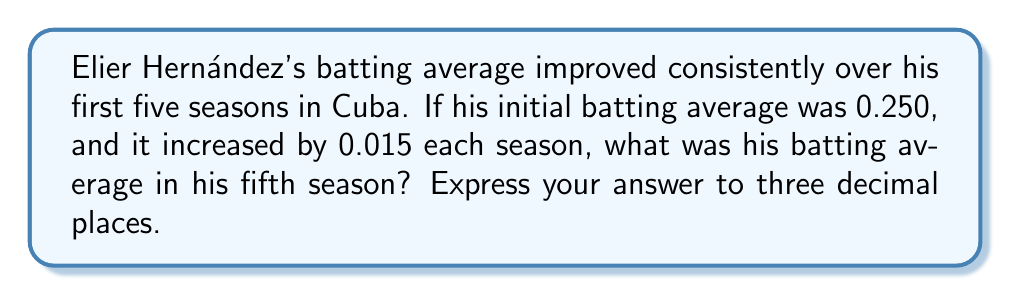Give your solution to this math problem. Let's approach this step-by-step:

1) We start with Hernández's initial batting average:
   $a_1 = 0.250$

2) We're told that his average increases by 0.015 each season. This forms an arithmetic sequence with a common difference of 0.015.

3) To find the fifth term in this sequence, we can use the arithmetic sequence formula:
   $a_n = a_1 + (n-1)d$
   Where:
   $a_n$ is the nth term
   $a_1$ is the first term
   $n$ is the position of the term we're looking for
   $d$ is the common difference

4) Plugging in our values:
   $a_5 = 0.250 + (5-1)(0.015)$

5) Simplify:
   $a_5 = 0.250 + (4)(0.015)$
   $a_5 = 0.250 + 0.060$

6) Calculate:
   $a_5 = 0.310$

Therefore, Hernández's batting average in his fifth season was 0.310.
Answer: 0.310 